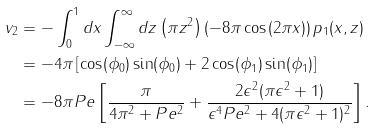Convert formula to latex. <formula><loc_0><loc_0><loc_500><loc_500>v _ { 2 } & = - \int _ { 0 } ^ { 1 } d x \int _ { - \infty } ^ { \infty } d z \left ( \pi z ^ { 2 } \right ) ( - 8 \pi \cos ( 2 \pi x ) ) \, p _ { 1 } ( x , z ) \\ & = - 4 \pi \left [ \cos ( \phi _ { 0 } ) \sin ( \phi _ { 0 } ) + 2 \cos ( \phi _ { 1 } ) \sin ( \phi _ { 1 } ) \right ] \\ & = - 8 \pi P e \left [ \frac { \pi } { 4 \pi ^ { 2 } + P e ^ { 2 } } + \frac { 2 \epsilon ^ { 2 } ( \pi \epsilon ^ { 2 } + 1 ) } { \epsilon ^ { 4 } P e ^ { 2 } + 4 ( \pi \epsilon ^ { 2 } + 1 ) ^ { 2 } } \right ] .</formula> 